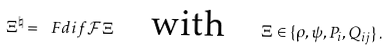Convert formula to latex. <formula><loc_0><loc_0><loc_500><loc_500>\Xi ^ { \natural } = \ F d i f { \mathcal { F } } { \Xi } \quad \text {with} \quad \Xi \in \{ \rho , \psi , P _ { i } , Q _ { i j } \} \, .</formula> 